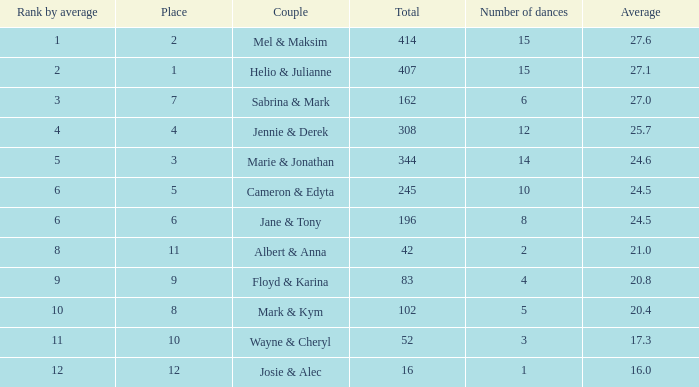What is the mean when the ranking by average surpasses 12? None. 